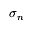<formula> <loc_0><loc_0><loc_500><loc_500>\sigma _ { n }</formula> 